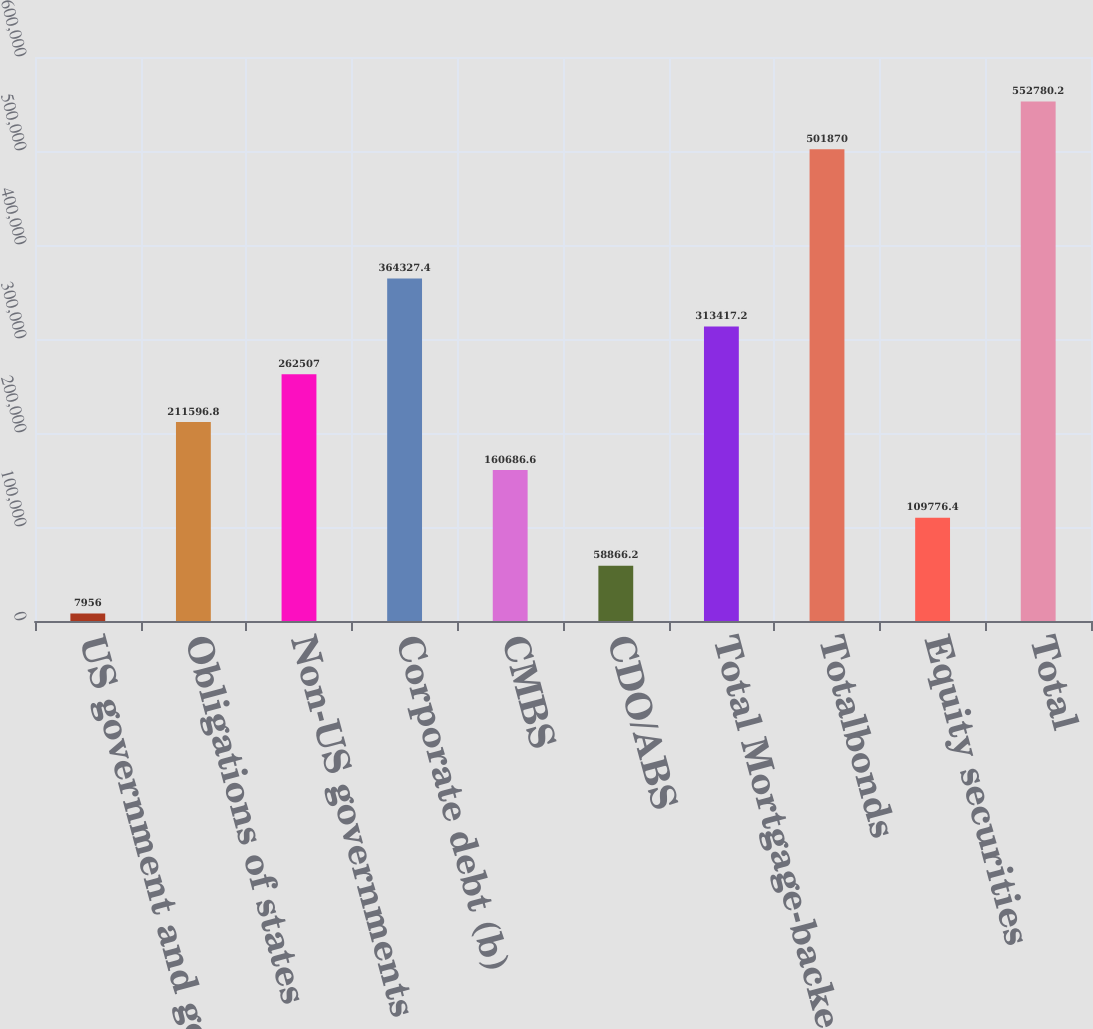Convert chart to OTSL. <chart><loc_0><loc_0><loc_500><loc_500><bar_chart><fcel>US government and government<fcel>Obligations of states<fcel>Non-US governments<fcel>Corporate debt (b)<fcel>CMBS<fcel>CDO/ABS<fcel>Total Mortgage-backed<fcel>Totalbonds<fcel>Equity securities<fcel>Total<nl><fcel>7956<fcel>211597<fcel>262507<fcel>364327<fcel>160687<fcel>58866.2<fcel>313417<fcel>501870<fcel>109776<fcel>552780<nl></chart> 